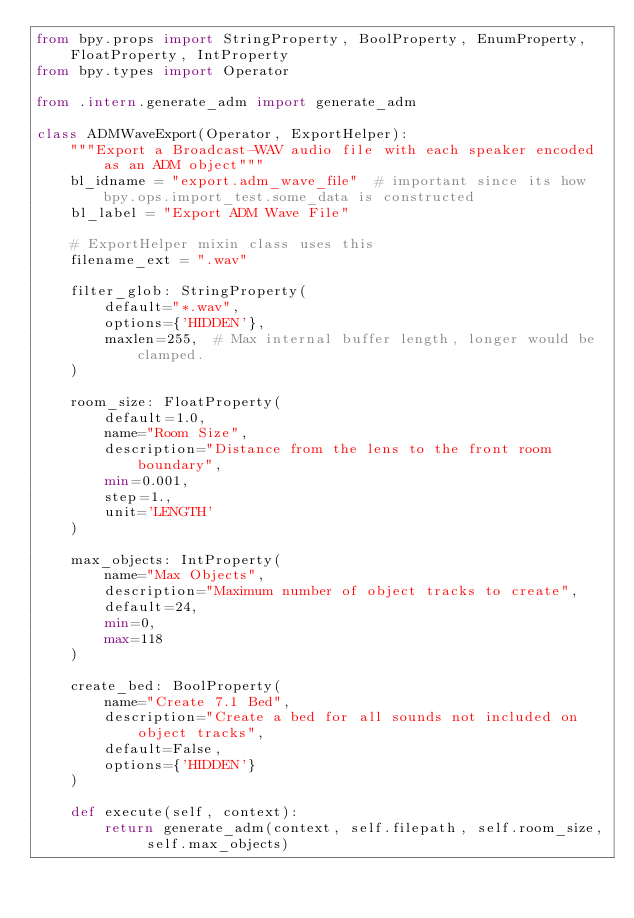<code> <loc_0><loc_0><loc_500><loc_500><_Python_>from bpy.props import StringProperty, BoolProperty, EnumProperty, FloatProperty, IntProperty
from bpy.types import Operator

from .intern.generate_adm import generate_adm

class ADMWaveExport(Operator, ExportHelper):
    """Export a Broadcast-WAV audio file with each speaker encoded as an ADM object"""
    bl_idname = "export.adm_wave_file"  # important since its how bpy.ops.import_test.some_data is constructed
    bl_label = "Export ADM Wave File"

    # ExportHelper mixin class uses this
    filename_ext = ".wav"

    filter_glob: StringProperty(
        default="*.wav",
        options={'HIDDEN'},
        maxlen=255,  # Max internal buffer length, longer would be clamped.
    )
    
    room_size: FloatProperty(
        default=1.0,
        name="Room Size",
        description="Distance from the lens to the front room boundary",
        min=0.001,
        step=1.,
        unit='LENGTH'
    )

    max_objects: IntProperty(
        name="Max Objects",
        description="Maximum number of object tracks to create",
        default=24,
        min=0,
        max=118
    )

    create_bed: BoolProperty(
        name="Create 7.1 Bed",
        description="Create a bed for all sounds not included on object tracks",
        default=False,
        options={'HIDDEN'}
    )

    def execute(self, context):
        return generate_adm(context, self.filepath, self.room_size, self.max_objects)

</code> 